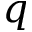<formula> <loc_0><loc_0><loc_500><loc_500>q</formula> 